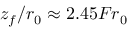<formula> <loc_0><loc_0><loc_500><loc_500>z _ { f } / r _ { 0 } \approx 2 . 4 5 F r _ { 0 }</formula> 